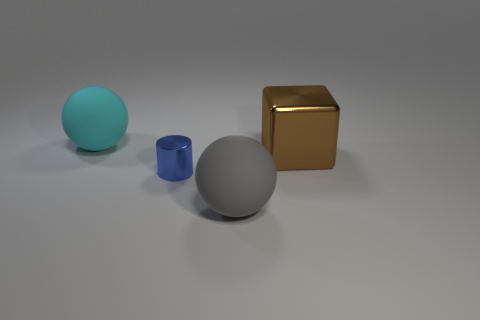Add 4 big cyan rubber cylinders. How many objects exist? 8 Subtract all cubes. How many objects are left? 3 Subtract 0 blue balls. How many objects are left? 4 Subtract all large rubber spheres. Subtract all yellow matte objects. How many objects are left? 2 Add 4 small metallic things. How many small metallic things are left? 5 Add 4 brown shiny things. How many brown shiny things exist? 5 